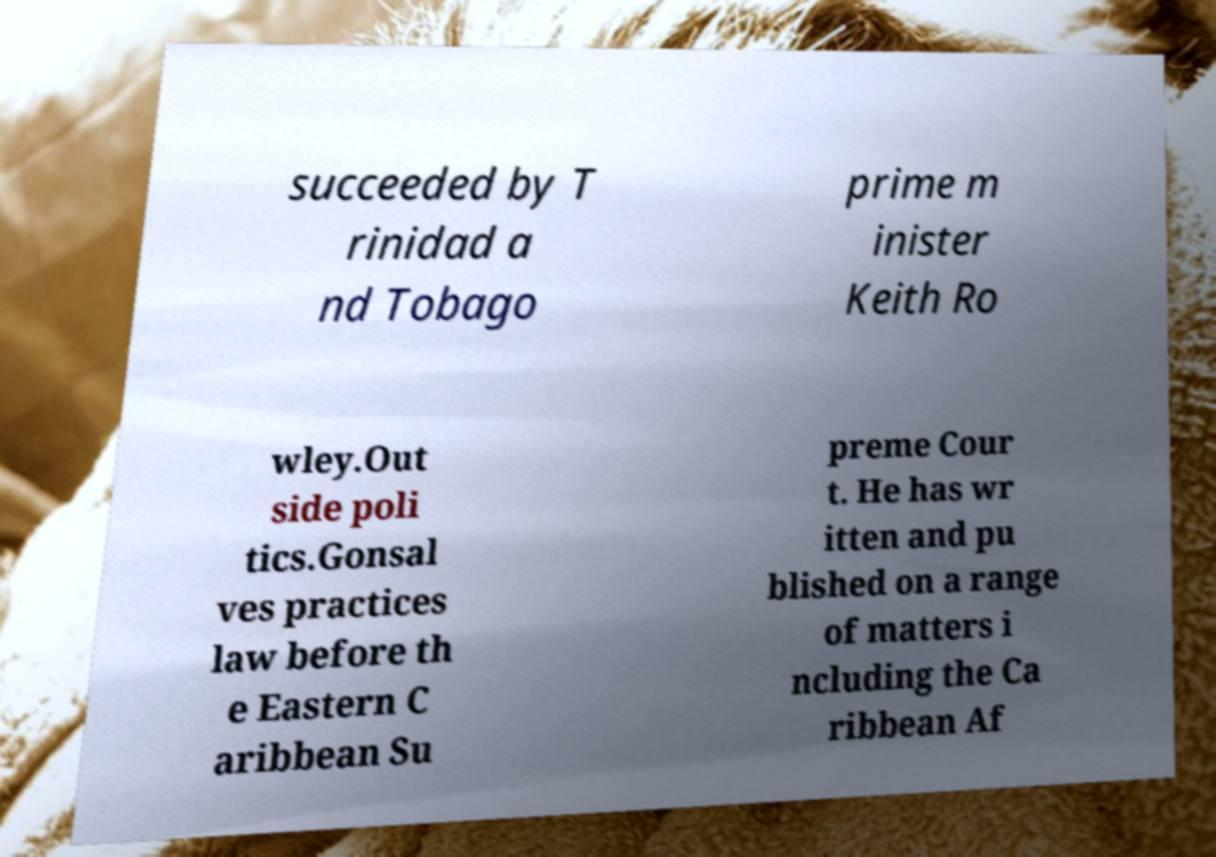Please identify and transcribe the text found in this image. succeeded by T rinidad a nd Tobago prime m inister Keith Ro wley.Out side poli tics.Gonsal ves practices law before th e Eastern C aribbean Su preme Cour t. He has wr itten and pu blished on a range of matters i ncluding the Ca ribbean Af 